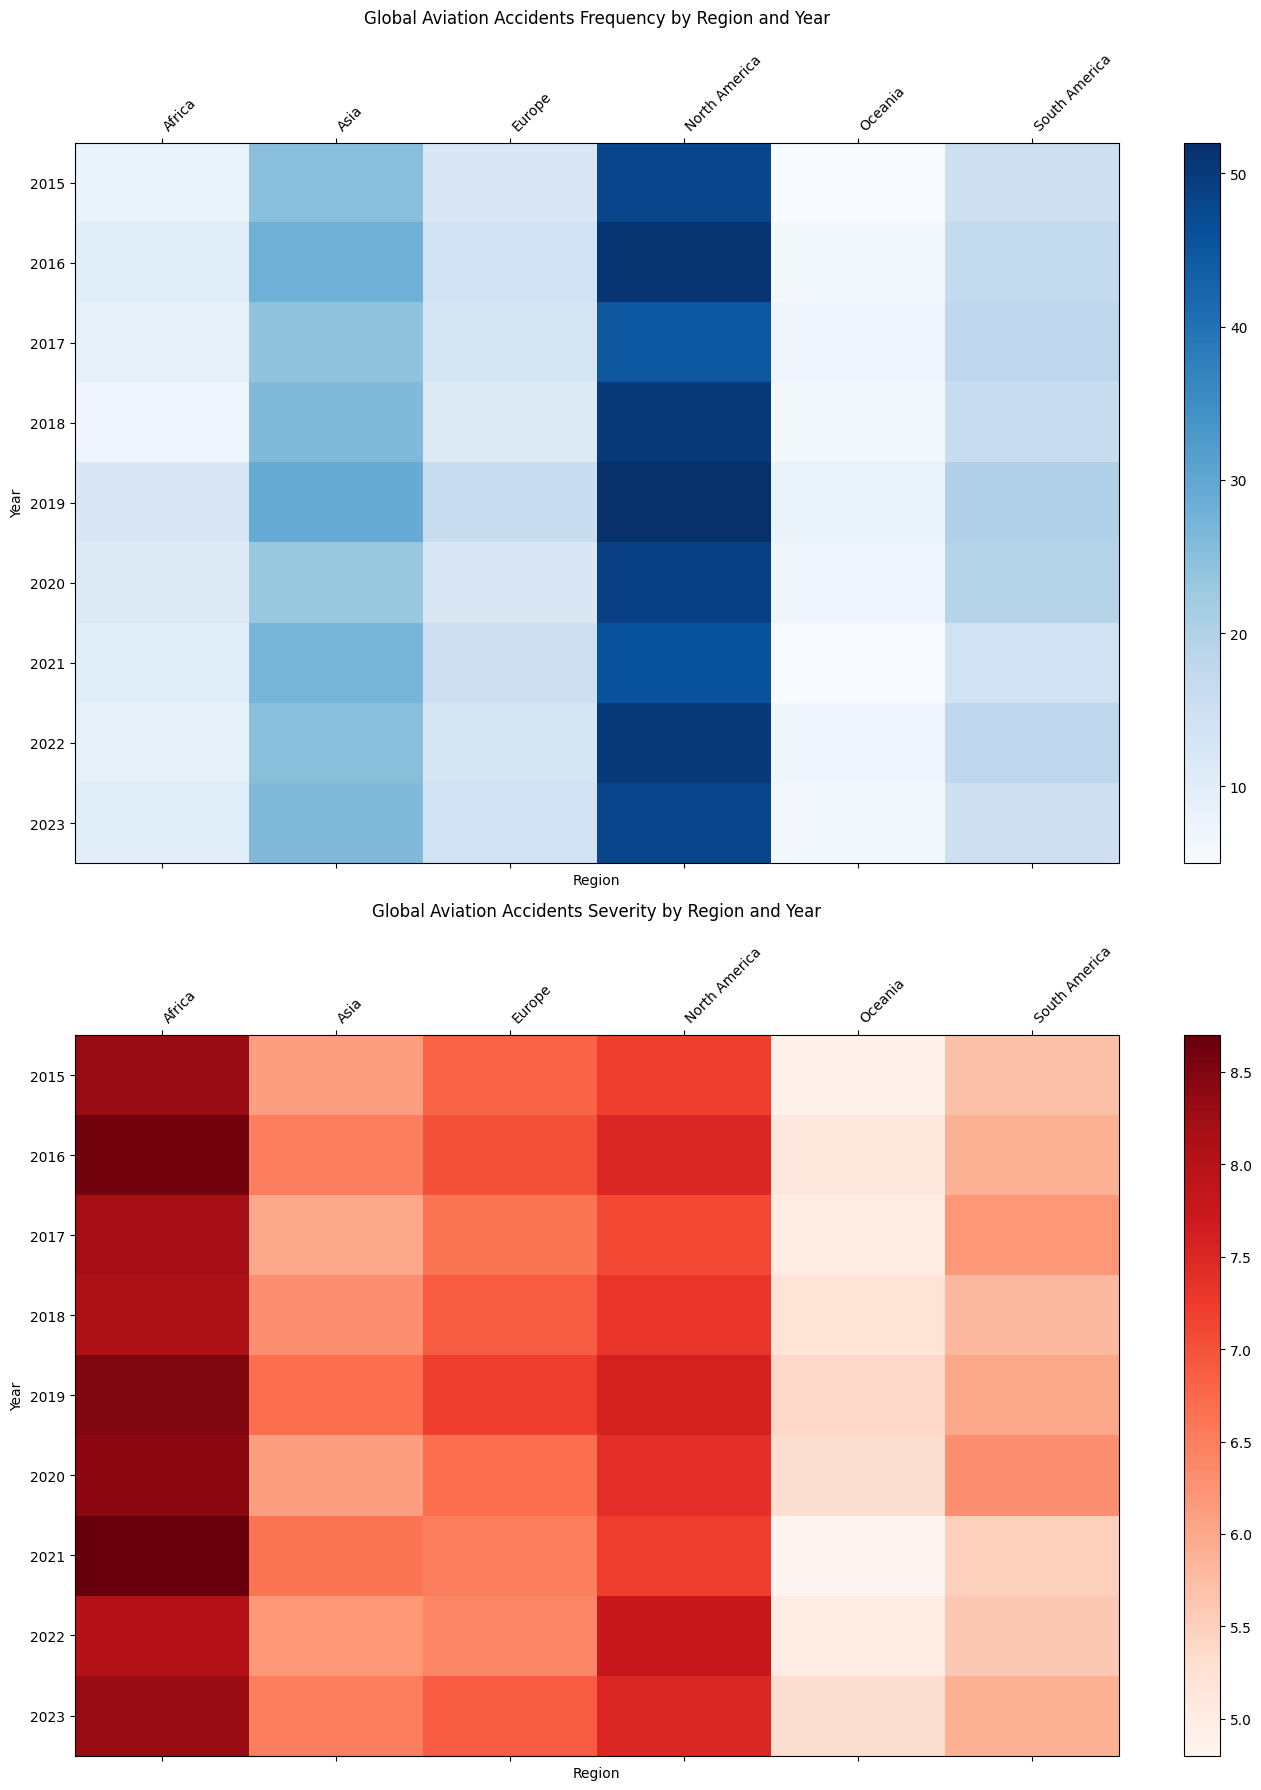Which region had the highest frequency of aviation accidents in 2020? Look at the frequency heatmap for the year 2020 and compare all regions. The brightest cell indicates the highest frequency. North America has the brightest cell in 2020.
Answer: North America Which year had the highest severity of aviation accidents in Africa? Check the severity heatmap for the cells related to Africa across all years. The darkest cell will indicate the highest severity. The darkest cell for Africa is in 2021.
Answer: 2021 Between 2018 and 2021, which year had the lowest frequency of aviation accidents in Europe? Compare the brightness of the cells for Europe from 2018 to 2021 in the frequency heatmap. The cell for 2018 is the faintest.
Answer: 2018 What is the average severity of aviation accidents in North America from 2015 to 2017? Look at the severity values for North America from 2015 to 2017: 7.2, 7.5, 7.1. Sum them up and divide by 3. (7.2 + 7.5 + 7.1) / 3 = 21.8 / 3 = 7.27.
Answer: 7.27 Which region had the most significant increase in the severity of aviation accidents from 2021 to 2022? Compare the severity values for each region from 2021 to 2022. Look for the largest difference: North America (7.2 to 7.8), Europe (6.5 to 6.4), Asia (6.6 to 6.2), South America (5.5 to 5.6), Africa (8.7 to 8.0), Oceania (4.8 to 5.0). North America has the most significant increase: 0.6.
Answer: North America Which region consistently had the highest severity of aviation accidents over the years? Look at the darkest cells across all years in the severity heatmap. Africa consistently has darker cells compared to other regions.
Answer: Africa What was the difference in the number of aviation accident frequencies in North America between 2019 and 2020? Look at the frequency numbers for North America in 2019 and 2020. Calculate the difference: 52 (2019) - 49 (2020) = 3.
Answer: 3 In which year did Oceania see its highest frequency of aviation accidents, and what was the severity in that year? Look at the frequency data for Oceania across all years and find the brightest cell. The brightest cell is in 2019. The severity in that year is given in the second heatmap: 5.4.
Answer: 2019, 5.4 What trend do you observe in the frequency of aviation accidents in South America from 2015 to 2023? Look at the frequency cells for South America from 2015 to 2023. The colors suggest a slight increasing trend with some fluctuations. Specifically, starting at 15, it goes to 14 to 18, indicating an overall increase but with variations.
Answer: Increasing with fluctuations 